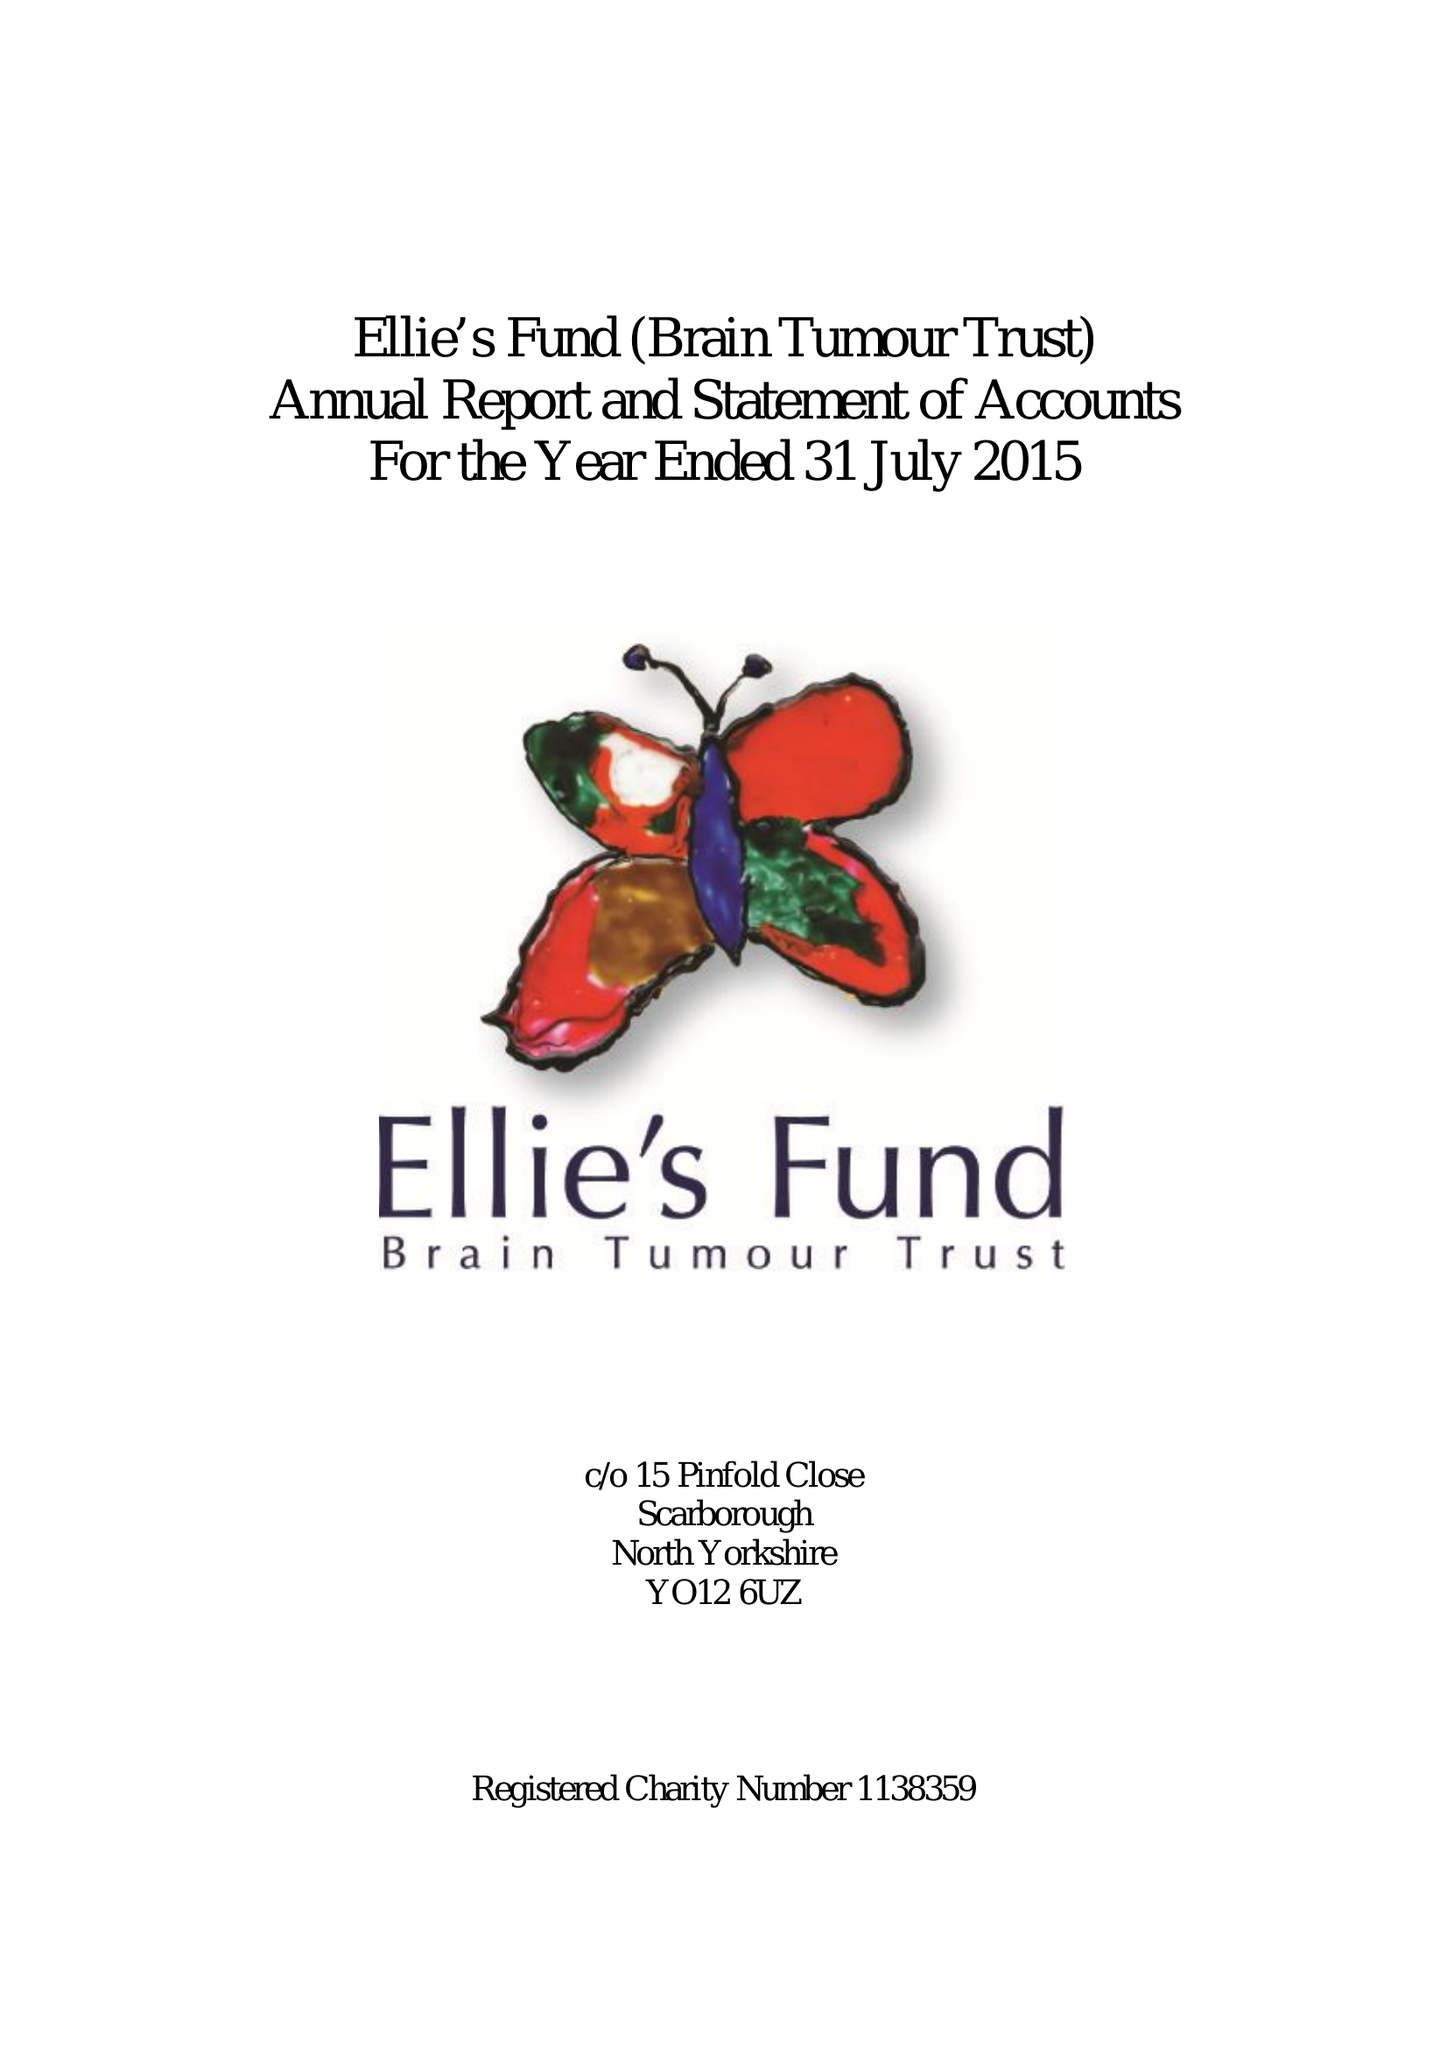What is the value for the spending_annually_in_british_pounds?
Answer the question using a single word or phrase. 49789.00 